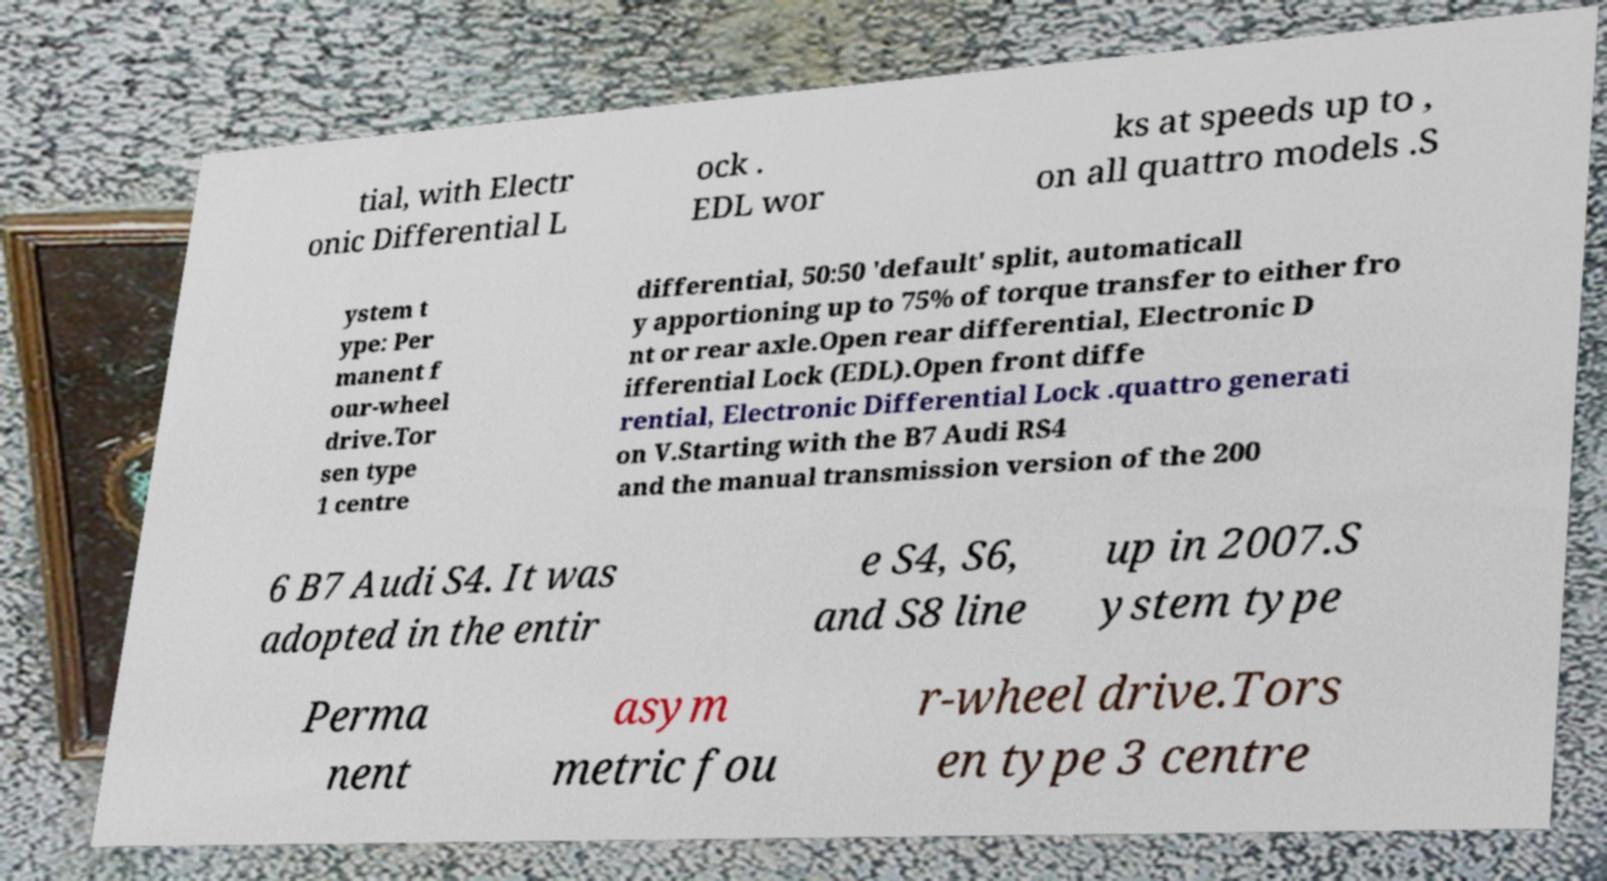Please read and relay the text visible in this image. What does it say? tial, with Electr onic Differential L ock . EDL wor ks at speeds up to , on all quattro models .S ystem t ype: Per manent f our-wheel drive.Tor sen type 1 centre differential, 50:50 'default' split, automaticall y apportioning up to 75% of torque transfer to either fro nt or rear axle.Open rear differential, Electronic D ifferential Lock (EDL).Open front diffe rential, Electronic Differential Lock .quattro generati on V.Starting with the B7 Audi RS4 and the manual transmission version of the 200 6 B7 Audi S4. It was adopted in the entir e S4, S6, and S8 line up in 2007.S ystem type Perma nent asym metric fou r-wheel drive.Tors en type 3 centre 